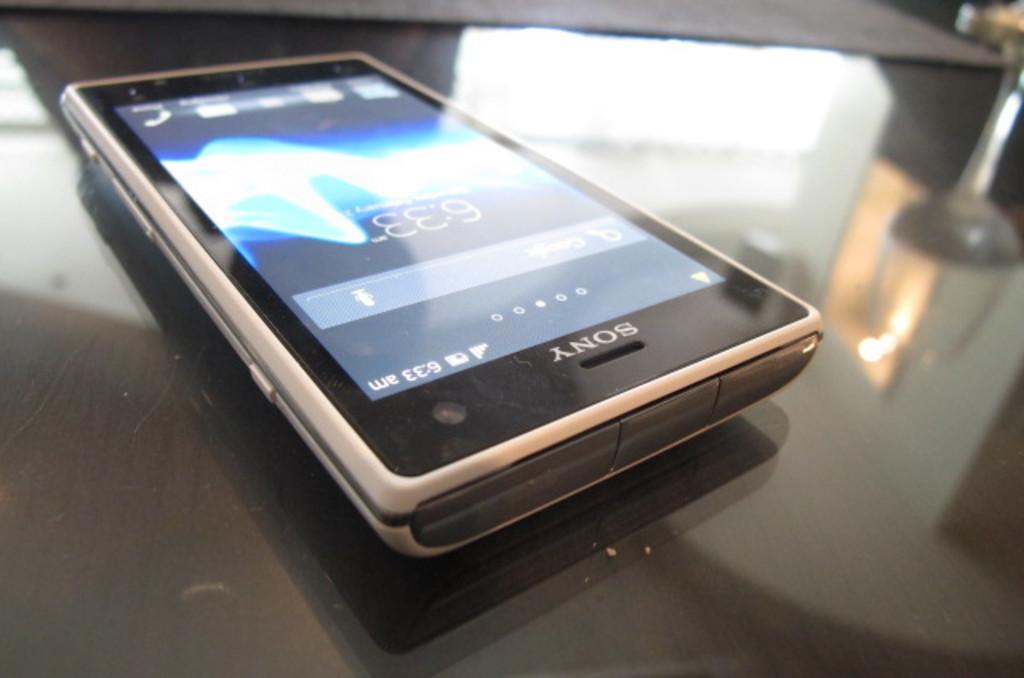<image>
Give a short and clear explanation of the subsequent image. A Sony phone is turned on and is on a table. 